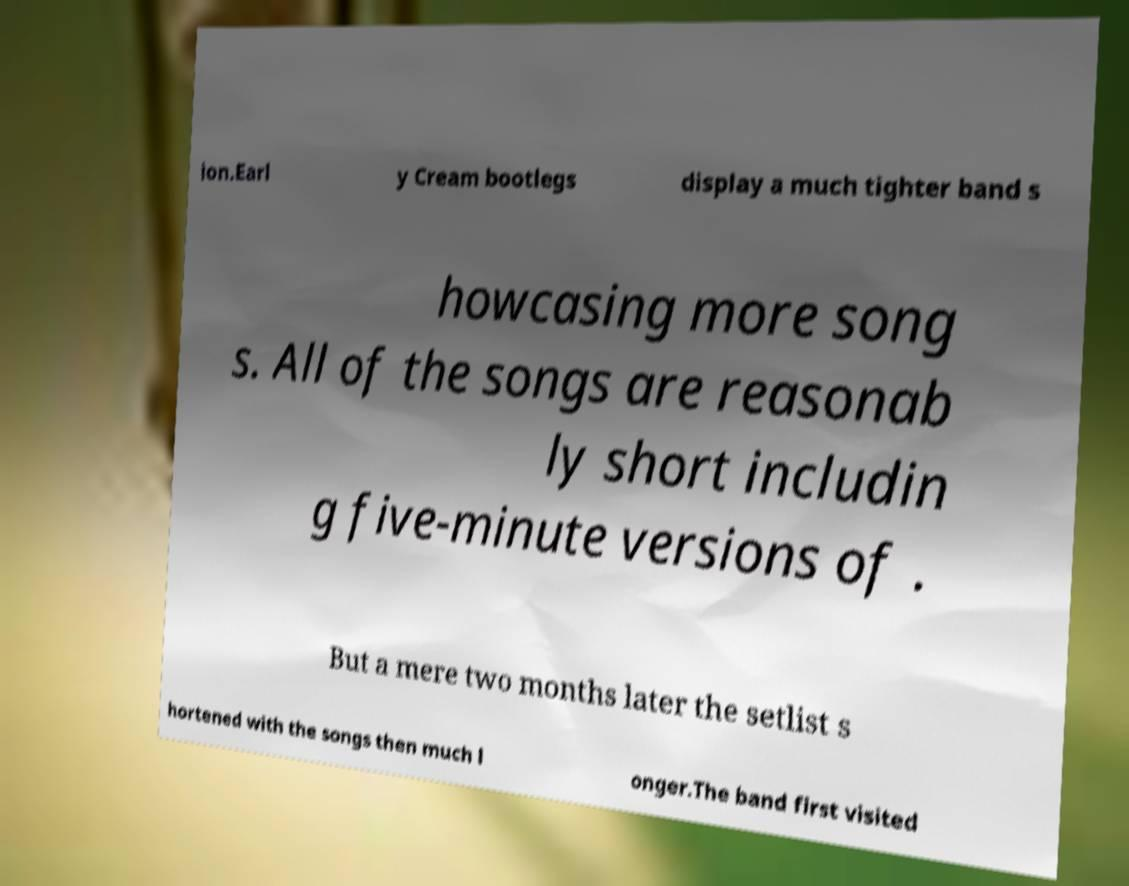Can you read and provide the text displayed in the image?This photo seems to have some interesting text. Can you extract and type it out for me? ion.Earl y Cream bootlegs display a much tighter band s howcasing more song s. All of the songs are reasonab ly short includin g five-minute versions of . But a mere two months later the setlist s hortened with the songs then much l onger.The band first visited 